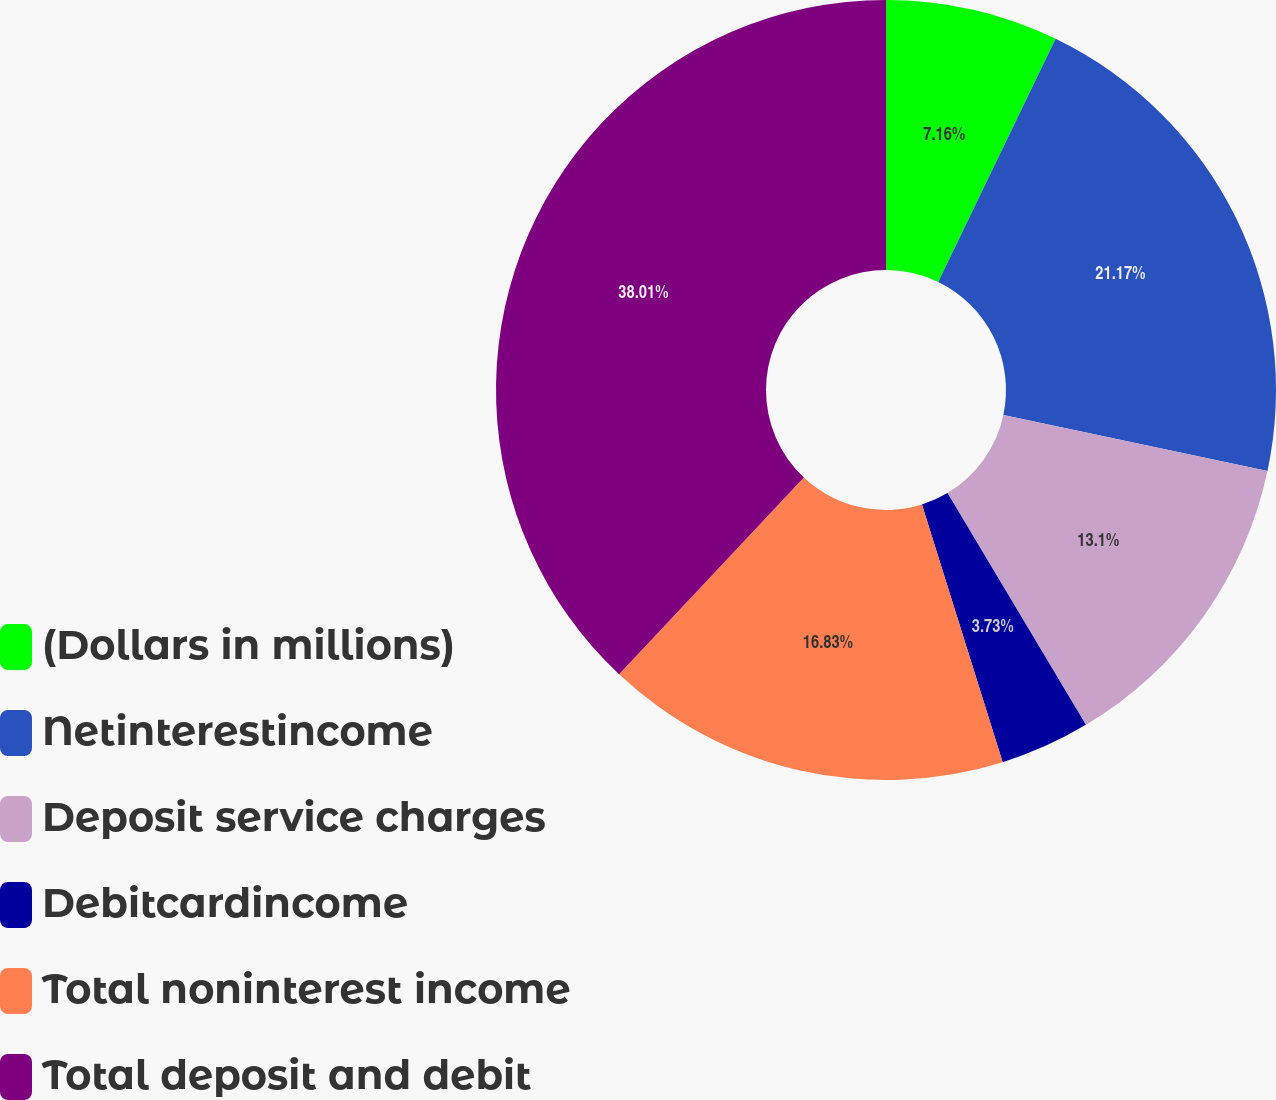<chart> <loc_0><loc_0><loc_500><loc_500><pie_chart><fcel>(Dollars in millions)<fcel>Netinterestincome<fcel>Deposit service charges<fcel>Debitcardincome<fcel>Total noninterest income<fcel>Total deposit and debit<nl><fcel>7.16%<fcel>21.17%<fcel>13.1%<fcel>3.73%<fcel>16.83%<fcel>38.0%<nl></chart> 